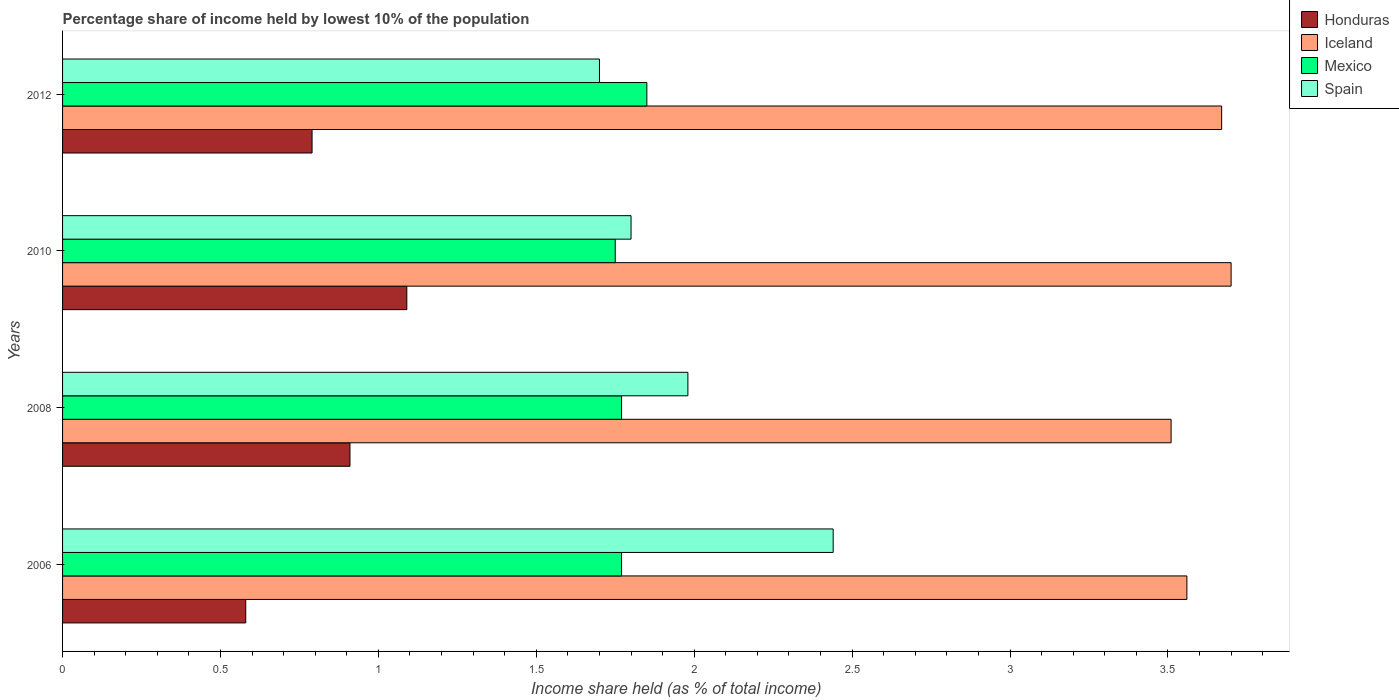How many bars are there on the 2nd tick from the top?
Keep it short and to the point. 4. What is the percentage share of income held by lowest 10% of the population in Mexico in 2008?
Keep it short and to the point. 1.77. Across all years, what is the maximum percentage share of income held by lowest 10% of the population in Honduras?
Your response must be concise. 1.09. Across all years, what is the minimum percentage share of income held by lowest 10% of the population in Iceland?
Provide a succinct answer. 3.51. In which year was the percentage share of income held by lowest 10% of the population in Iceland maximum?
Your answer should be compact. 2010. In which year was the percentage share of income held by lowest 10% of the population in Spain minimum?
Your answer should be very brief. 2012. What is the total percentage share of income held by lowest 10% of the population in Iceland in the graph?
Offer a terse response. 14.44. What is the difference between the percentage share of income held by lowest 10% of the population in Iceland in 2010 and that in 2012?
Keep it short and to the point. 0.03. What is the difference between the percentage share of income held by lowest 10% of the population in Iceland in 2008 and the percentage share of income held by lowest 10% of the population in Honduras in 2012?
Ensure brevity in your answer.  2.72. What is the average percentage share of income held by lowest 10% of the population in Mexico per year?
Offer a terse response. 1.79. In the year 2010, what is the difference between the percentage share of income held by lowest 10% of the population in Honduras and percentage share of income held by lowest 10% of the population in Iceland?
Keep it short and to the point. -2.61. What is the ratio of the percentage share of income held by lowest 10% of the population in Honduras in 2010 to that in 2012?
Ensure brevity in your answer.  1.38. Is the percentage share of income held by lowest 10% of the population in Honduras in 2008 less than that in 2012?
Your answer should be very brief. No. What is the difference between the highest and the second highest percentage share of income held by lowest 10% of the population in Honduras?
Your answer should be compact. 0.18. What is the difference between the highest and the lowest percentage share of income held by lowest 10% of the population in Spain?
Make the answer very short. 0.74. In how many years, is the percentage share of income held by lowest 10% of the population in Spain greater than the average percentage share of income held by lowest 10% of the population in Spain taken over all years?
Ensure brevity in your answer.  1. What does the 4th bar from the top in 2008 represents?
Keep it short and to the point. Honduras. What does the 3rd bar from the bottom in 2008 represents?
Keep it short and to the point. Mexico. What is the difference between two consecutive major ticks on the X-axis?
Ensure brevity in your answer.  0.5. Does the graph contain any zero values?
Provide a succinct answer. No. Does the graph contain grids?
Provide a short and direct response. No. Where does the legend appear in the graph?
Your response must be concise. Top right. How many legend labels are there?
Offer a very short reply. 4. How are the legend labels stacked?
Offer a terse response. Vertical. What is the title of the graph?
Make the answer very short. Percentage share of income held by lowest 10% of the population. What is the label or title of the X-axis?
Give a very brief answer. Income share held (as % of total income). What is the Income share held (as % of total income) in Honduras in 2006?
Ensure brevity in your answer.  0.58. What is the Income share held (as % of total income) of Iceland in 2006?
Offer a terse response. 3.56. What is the Income share held (as % of total income) in Mexico in 2006?
Provide a succinct answer. 1.77. What is the Income share held (as % of total income) in Spain in 2006?
Make the answer very short. 2.44. What is the Income share held (as % of total income) of Honduras in 2008?
Ensure brevity in your answer.  0.91. What is the Income share held (as % of total income) in Iceland in 2008?
Your answer should be very brief. 3.51. What is the Income share held (as % of total income) of Mexico in 2008?
Give a very brief answer. 1.77. What is the Income share held (as % of total income) of Spain in 2008?
Provide a short and direct response. 1.98. What is the Income share held (as % of total income) in Honduras in 2010?
Keep it short and to the point. 1.09. What is the Income share held (as % of total income) of Iceland in 2010?
Give a very brief answer. 3.7. What is the Income share held (as % of total income) of Mexico in 2010?
Make the answer very short. 1.75. What is the Income share held (as % of total income) of Spain in 2010?
Your answer should be compact. 1.8. What is the Income share held (as % of total income) of Honduras in 2012?
Offer a very short reply. 0.79. What is the Income share held (as % of total income) of Iceland in 2012?
Provide a short and direct response. 3.67. What is the Income share held (as % of total income) in Mexico in 2012?
Ensure brevity in your answer.  1.85. What is the Income share held (as % of total income) in Spain in 2012?
Offer a very short reply. 1.7. Across all years, what is the maximum Income share held (as % of total income) of Honduras?
Provide a short and direct response. 1.09. Across all years, what is the maximum Income share held (as % of total income) of Iceland?
Offer a terse response. 3.7. Across all years, what is the maximum Income share held (as % of total income) in Mexico?
Give a very brief answer. 1.85. Across all years, what is the maximum Income share held (as % of total income) in Spain?
Ensure brevity in your answer.  2.44. Across all years, what is the minimum Income share held (as % of total income) of Honduras?
Your answer should be very brief. 0.58. Across all years, what is the minimum Income share held (as % of total income) in Iceland?
Your answer should be compact. 3.51. Across all years, what is the minimum Income share held (as % of total income) in Mexico?
Make the answer very short. 1.75. What is the total Income share held (as % of total income) in Honduras in the graph?
Give a very brief answer. 3.37. What is the total Income share held (as % of total income) in Iceland in the graph?
Your answer should be very brief. 14.44. What is the total Income share held (as % of total income) of Mexico in the graph?
Provide a succinct answer. 7.14. What is the total Income share held (as % of total income) in Spain in the graph?
Ensure brevity in your answer.  7.92. What is the difference between the Income share held (as % of total income) of Honduras in 2006 and that in 2008?
Offer a terse response. -0.33. What is the difference between the Income share held (as % of total income) in Spain in 2006 and that in 2008?
Your response must be concise. 0.46. What is the difference between the Income share held (as % of total income) of Honduras in 2006 and that in 2010?
Your response must be concise. -0.51. What is the difference between the Income share held (as % of total income) in Iceland in 2006 and that in 2010?
Your response must be concise. -0.14. What is the difference between the Income share held (as % of total income) of Spain in 2006 and that in 2010?
Your answer should be compact. 0.64. What is the difference between the Income share held (as % of total income) of Honduras in 2006 and that in 2012?
Provide a short and direct response. -0.21. What is the difference between the Income share held (as % of total income) in Iceland in 2006 and that in 2012?
Keep it short and to the point. -0.11. What is the difference between the Income share held (as % of total income) of Mexico in 2006 and that in 2012?
Ensure brevity in your answer.  -0.08. What is the difference between the Income share held (as % of total income) in Spain in 2006 and that in 2012?
Make the answer very short. 0.74. What is the difference between the Income share held (as % of total income) in Honduras in 2008 and that in 2010?
Your response must be concise. -0.18. What is the difference between the Income share held (as % of total income) of Iceland in 2008 and that in 2010?
Give a very brief answer. -0.19. What is the difference between the Income share held (as % of total income) in Spain in 2008 and that in 2010?
Give a very brief answer. 0.18. What is the difference between the Income share held (as % of total income) of Honduras in 2008 and that in 2012?
Provide a succinct answer. 0.12. What is the difference between the Income share held (as % of total income) in Iceland in 2008 and that in 2012?
Your answer should be compact. -0.16. What is the difference between the Income share held (as % of total income) of Mexico in 2008 and that in 2012?
Your response must be concise. -0.08. What is the difference between the Income share held (as % of total income) in Spain in 2008 and that in 2012?
Your answer should be compact. 0.28. What is the difference between the Income share held (as % of total income) in Spain in 2010 and that in 2012?
Keep it short and to the point. 0.1. What is the difference between the Income share held (as % of total income) in Honduras in 2006 and the Income share held (as % of total income) in Iceland in 2008?
Your response must be concise. -2.93. What is the difference between the Income share held (as % of total income) of Honduras in 2006 and the Income share held (as % of total income) of Mexico in 2008?
Provide a succinct answer. -1.19. What is the difference between the Income share held (as % of total income) in Honduras in 2006 and the Income share held (as % of total income) in Spain in 2008?
Give a very brief answer. -1.4. What is the difference between the Income share held (as % of total income) in Iceland in 2006 and the Income share held (as % of total income) in Mexico in 2008?
Your answer should be very brief. 1.79. What is the difference between the Income share held (as % of total income) of Iceland in 2006 and the Income share held (as % of total income) of Spain in 2008?
Your answer should be very brief. 1.58. What is the difference between the Income share held (as % of total income) in Mexico in 2006 and the Income share held (as % of total income) in Spain in 2008?
Give a very brief answer. -0.21. What is the difference between the Income share held (as % of total income) in Honduras in 2006 and the Income share held (as % of total income) in Iceland in 2010?
Give a very brief answer. -3.12. What is the difference between the Income share held (as % of total income) in Honduras in 2006 and the Income share held (as % of total income) in Mexico in 2010?
Offer a terse response. -1.17. What is the difference between the Income share held (as % of total income) of Honduras in 2006 and the Income share held (as % of total income) of Spain in 2010?
Your answer should be very brief. -1.22. What is the difference between the Income share held (as % of total income) of Iceland in 2006 and the Income share held (as % of total income) of Mexico in 2010?
Provide a short and direct response. 1.81. What is the difference between the Income share held (as % of total income) of Iceland in 2006 and the Income share held (as % of total income) of Spain in 2010?
Offer a terse response. 1.76. What is the difference between the Income share held (as % of total income) in Mexico in 2006 and the Income share held (as % of total income) in Spain in 2010?
Your response must be concise. -0.03. What is the difference between the Income share held (as % of total income) in Honduras in 2006 and the Income share held (as % of total income) in Iceland in 2012?
Give a very brief answer. -3.09. What is the difference between the Income share held (as % of total income) of Honduras in 2006 and the Income share held (as % of total income) of Mexico in 2012?
Give a very brief answer. -1.27. What is the difference between the Income share held (as % of total income) in Honduras in 2006 and the Income share held (as % of total income) in Spain in 2012?
Offer a very short reply. -1.12. What is the difference between the Income share held (as % of total income) of Iceland in 2006 and the Income share held (as % of total income) of Mexico in 2012?
Make the answer very short. 1.71. What is the difference between the Income share held (as % of total income) of Iceland in 2006 and the Income share held (as % of total income) of Spain in 2012?
Provide a succinct answer. 1.86. What is the difference between the Income share held (as % of total income) in Mexico in 2006 and the Income share held (as % of total income) in Spain in 2012?
Offer a terse response. 0.07. What is the difference between the Income share held (as % of total income) of Honduras in 2008 and the Income share held (as % of total income) of Iceland in 2010?
Provide a succinct answer. -2.79. What is the difference between the Income share held (as % of total income) of Honduras in 2008 and the Income share held (as % of total income) of Mexico in 2010?
Offer a terse response. -0.84. What is the difference between the Income share held (as % of total income) of Honduras in 2008 and the Income share held (as % of total income) of Spain in 2010?
Make the answer very short. -0.89. What is the difference between the Income share held (as % of total income) of Iceland in 2008 and the Income share held (as % of total income) of Mexico in 2010?
Keep it short and to the point. 1.76. What is the difference between the Income share held (as % of total income) of Iceland in 2008 and the Income share held (as % of total income) of Spain in 2010?
Make the answer very short. 1.71. What is the difference between the Income share held (as % of total income) of Mexico in 2008 and the Income share held (as % of total income) of Spain in 2010?
Provide a succinct answer. -0.03. What is the difference between the Income share held (as % of total income) of Honduras in 2008 and the Income share held (as % of total income) of Iceland in 2012?
Your response must be concise. -2.76. What is the difference between the Income share held (as % of total income) in Honduras in 2008 and the Income share held (as % of total income) in Mexico in 2012?
Your answer should be very brief. -0.94. What is the difference between the Income share held (as % of total income) of Honduras in 2008 and the Income share held (as % of total income) of Spain in 2012?
Provide a succinct answer. -0.79. What is the difference between the Income share held (as % of total income) of Iceland in 2008 and the Income share held (as % of total income) of Mexico in 2012?
Ensure brevity in your answer.  1.66. What is the difference between the Income share held (as % of total income) in Iceland in 2008 and the Income share held (as % of total income) in Spain in 2012?
Your answer should be compact. 1.81. What is the difference between the Income share held (as % of total income) of Mexico in 2008 and the Income share held (as % of total income) of Spain in 2012?
Your answer should be compact. 0.07. What is the difference between the Income share held (as % of total income) in Honduras in 2010 and the Income share held (as % of total income) in Iceland in 2012?
Give a very brief answer. -2.58. What is the difference between the Income share held (as % of total income) in Honduras in 2010 and the Income share held (as % of total income) in Mexico in 2012?
Offer a terse response. -0.76. What is the difference between the Income share held (as % of total income) in Honduras in 2010 and the Income share held (as % of total income) in Spain in 2012?
Ensure brevity in your answer.  -0.61. What is the difference between the Income share held (as % of total income) in Iceland in 2010 and the Income share held (as % of total income) in Mexico in 2012?
Keep it short and to the point. 1.85. What is the difference between the Income share held (as % of total income) of Mexico in 2010 and the Income share held (as % of total income) of Spain in 2012?
Provide a succinct answer. 0.05. What is the average Income share held (as % of total income) in Honduras per year?
Your answer should be very brief. 0.84. What is the average Income share held (as % of total income) in Iceland per year?
Ensure brevity in your answer.  3.61. What is the average Income share held (as % of total income) of Mexico per year?
Your response must be concise. 1.78. What is the average Income share held (as % of total income) in Spain per year?
Provide a succinct answer. 1.98. In the year 2006, what is the difference between the Income share held (as % of total income) of Honduras and Income share held (as % of total income) of Iceland?
Give a very brief answer. -2.98. In the year 2006, what is the difference between the Income share held (as % of total income) of Honduras and Income share held (as % of total income) of Mexico?
Make the answer very short. -1.19. In the year 2006, what is the difference between the Income share held (as % of total income) in Honduras and Income share held (as % of total income) in Spain?
Give a very brief answer. -1.86. In the year 2006, what is the difference between the Income share held (as % of total income) of Iceland and Income share held (as % of total income) of Mexico?
Offer a very short reply. 1.79. In the year 2006, what is the difference between the Income share held (as % of total income) of Iceland and Income share held (as % of total income) of Spain?
Give a very brief answer. 1.12. In the year 2006, what is the difference between the Income share held (as % of total income) of Mexico and Income share held (as % of total income) of Spain?
Your answer should be compact. -0.67. In the year 2008, what is the difference between the Income share held (as % of total income) of Honduras and Income share held (as % of total income) of Mexico?
Make the answer very short. -0.86. In the year 2008, what is the difference between the Income share held (as % of total income) in Honduras and Income share held (as % of total income) in Spain?
Keep it short and to the point. -1.07. In the year 2008, what is the difference between the Income share held (as % of total income) in Iceland and Income share held (as % of total income) in Mexico?
Offer a very short reply. 1.74. In the year 2008, what is the difference between the Income share held (as % of total income) in Iceland and Income share held (as % of total income) in Spain?
Your response must be concise. 1.53. In the year 2008, what is the difference between the Income share held (as % of total income) in Mexico and Income share held (as % of total income) in Spain?
Your answer should be very brief. -0.21. In the year 2010, what is the difference between the Income share held (as % of total income) in Honduras and Income share held (as % of total income) in Iceland?
Your answer should be compact. -2.61. In the year 2010, what is the difference between the Income share held (as % of total income) of Honduras and Income share held (as % of total income) of Mexico?
Provide a succinct answer. -0.66. In the year 2010, what is the difference between the Income share held (as % of total income) in Honduras and Income share held (as % of total income) in Spain?
Ensure brevity in your answer.  -0.71. In the year 2010, what is the difference between the Income share held (as % of total income) in Iceland and Income share held (as % of total income) in Mexico?
Your response must be concise. 1.95. In the year 2010, what is the difference between the Income share held (as % of total income) in Iceland and Income share held (as % of total income) in Spain?
Offer a very short reply. 1.9. In the year 2012, what is the difference between the Income share held (as % of total income) in Honduras and Income share held (as % of total income) in Iceland?
Your answer should be very brief. -2.88. In the year 2012, what is the difference between the Income share held (as % of total income) of Honduras and Income share held (as % of total income) of Mexico?
Your response must be concise. -1.06. In the year 2012, what is the difference between the Income share held (as % of total income) in Honduras and Income share held (as % of total income) in Spain?
Provide a succinct answer. -0.91. In the year 2012, what is the difference between the Income share held (as % of total income) in Iceland and Income share held (as % of total income) in Mexico?
Your answer should be very brief. 1.82. In the year 2012, what is the difference between the Income share held (as % of total income) of Iceland and Income share held (as % of total income) of Spain?
Ensure brevity in your answer.  1.97. What is the ratio of the Income share held (as % of total income) of Honduras in 2006 to that in 2008?
Your answer should be compact. 0.64. What is the ratio of the Income share held (as % of total income) in Iceland in 2006 to that in 2008?
Offer a very short reply. 1.01. What is the ratio of the Income share held (as % of total income) of Mexico in 2006 to that in 2008?
Give a very brief answer. 1. What is the ratio of the Income share held (as % of total income) in Spain in 2006 to that in 2008?
Provide a short and direct response. 1.23. What is the ratio of the Income share held (as % of total income) of Honduras in 2006 to that in 2010?
Offer a terse response. 0.53. What is the ratio of the Income share held (as % of total income) of Iceland in 2006 to that in 2010?
Your answer should be compact. 0.96. What is the ratio of the Income share held (as % of total income) of Mexico in 2006 to that in 2010?
Your answer should be very brief. 1.01. What is the ratio of the Income share held (as % of total income) of Spain in 2006 to that in 2010?
Your answer should be very brief. 1.36. What is the ratio of the Income share held (as % of total income) in Honduras in 2006 to that in 2012?
Ensure brevity in your answer.  0.73. What is the ratio of the Income share held (as % of total income) of Mexico in 2006 to that in 2012?
Provide a short and direct response. 0.96. What is the ratio of the Income share held (as % of total income) in Spain in 2006 to that in 2012?
Make the answer very short. 1.44. What is the ratio of the Income share held (as % of total income) of Honduras in 2008 to that in 2010?
Offer a terse response. 0.83. What is the ratio of the Income share held (as % of total income) of Iceland in 2008 to that in 2010?
Your answer should be very brief. 0.95. What is the ratio of the Income share held (as % of total income) in Mexico in 2008 to that in 2010?
Provide a succinct answer. 1.01. What is the ratio of the Income share held (as % of total income) in Honduras in 2008 to that in 2012?
Ensure brevity in your answer.  1.15. What is the ratio of the Income share held (as % of total income) in Iceland in 2008 to that in 2012?
Your answer should be compact. 0.96. What is the ratio of the Income share held (as % of total income) in Mexico in 2008 to that in 2012?
Keep it short and to the point. 0.96. What is the ratio of the Income share held (as % of total income) in Spain in 2008 to that in 2012?
Offer a very short reply. 1.16. What is the ratio of the Income share held (as % of total income) of Honduras in 2010 to that in 2012?
Your answer should be very brief. 1.38. What is the ratio of the Income share held (as % of total income) in Iceland in 2010 to that in 2012?
Offer a very short reply. 1.01. What is the ratio of the Income share held (as % of total income) in Mexico in 2010 to that in 2012?
Offer a very short reply. 0.95. What is the ratio of the Income share held (as % of total income) of Spain in 2010 to that in 2012?
Your response must be concise. 1.06. What is the difference between the highest and the second highest Income share held (as % of total income) of Honduras?
Offer a very short reply. 0.18. What is the difference between the highest and the second highest Income share held (as % of total income) in Mexico?
Provide a short and direct response. 0.08. What is the difference between the highest and the second highest Income share held (as % of total income) in Spain?
Ensure brevity in your answer.  0.46. What is the difference between the highest and the lowest Income share held (as % of total income) of Honduras?
Ensure brevity in your answer.  0.51. What is the difference between the highest and the lowest Income share held (as % of total income) of Iceland?
Ensure brevity in your answer.  0.19. What is the difference between the highest and the lowest Income share held (as % of total income) in Spain?
Provide a succinct answer. 0.74. 